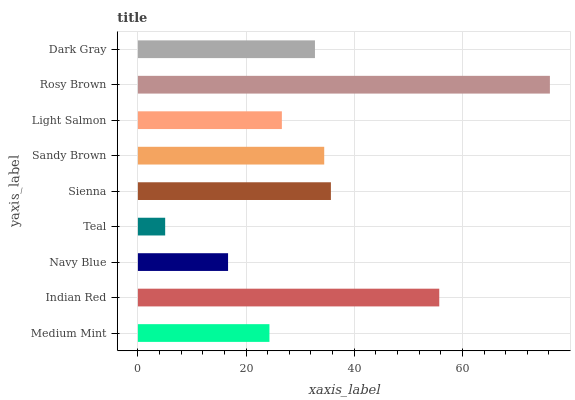Is Teal the minimum?
Answer yes or no. Yes. Is Rosy Brown the maximum?
Answer yes or no. Yes. Is Indian Red the minimum?
Answer yes or no. No. Is Indian Red the maximum?
Answer yes or no. No. Is Indian Red greater than Medium Mint?
Answer yes or no. Yes. Is Medium Mint less than Indian Red?
Answer yes or no. Yes. Is Medium Mint greater than Indian Red?
Answer yes or no. No. Is Indian Red less than Medium Mint?
Answer yes or no. No. Is Dark Gray the high median?
Answer yes or no. Yes. Is Dark Gray the low median?
Answer yes or no. Yes. Is Indian Red the high median?
Answer yes or no. No. Is Teal the low median?
Answer yes or no. No. 